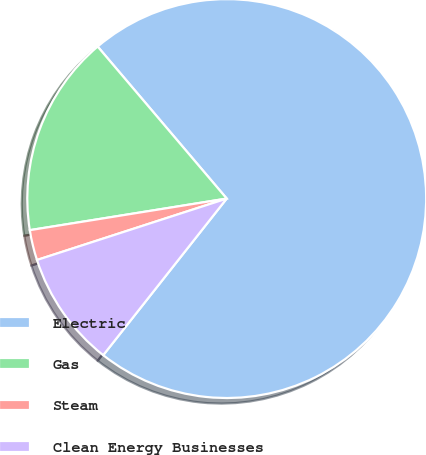<chart> <loc_0><loc_0><loc_500><loc_500><pie_chart><fcel>Electric<fcel>Gas<fcel>Steam<fcel>Clean Energy Businesses<nl><fcel>71.84%<fcel>16.33%<fcel>2.45%<fcel>9.39%<nl></chart> 